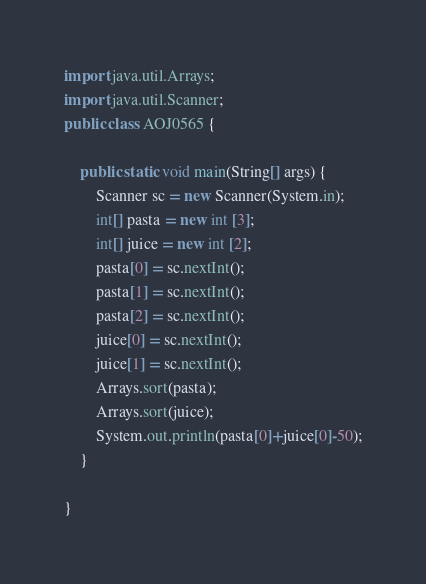Convert code to text. <code><loc_0><loc_0><loc_500><loc_500><_Java_>import java.util.Arrays;
import java.util.Scanner;
public class AOJ0565 {

	public static void main(String[] args) {
		Scanner sc = new Scanner(System.in);
		int[] pasta = new int [3];
		int[] juice = new int [2];
		pasta[0] = sc.nextInt();
		pasta[1] = sc.nextInt();
		pasta[2] = sc.nextInt();
        juice[0] = sc.nextInt();
        juice[1] = sc.nextInt();
        Arrays.sort(pasta);
        Arrays.sort(juice);
        System.out.println(pasta[0]+juice[0]-50);
	}

}</code> 